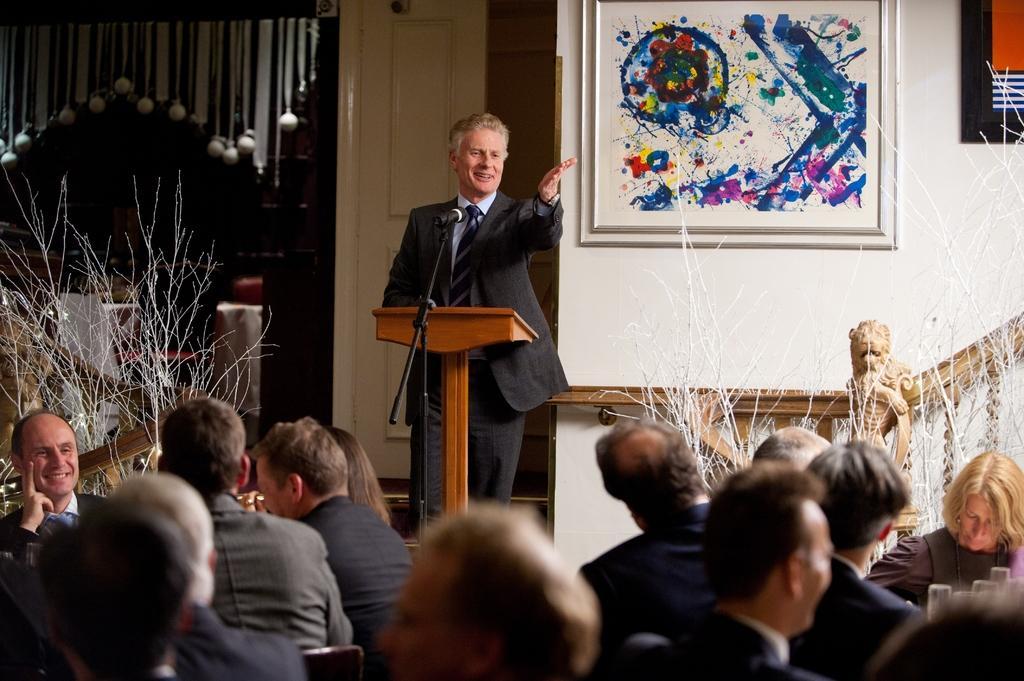Describe this image in one or two sentences. In the center of the image there is a person standing at the lectern with mic. At the bottom there are persons. On the right side of the image we can see painting and a tree. On the left side of the image we can see a tree. In the background there is a door and wall. 